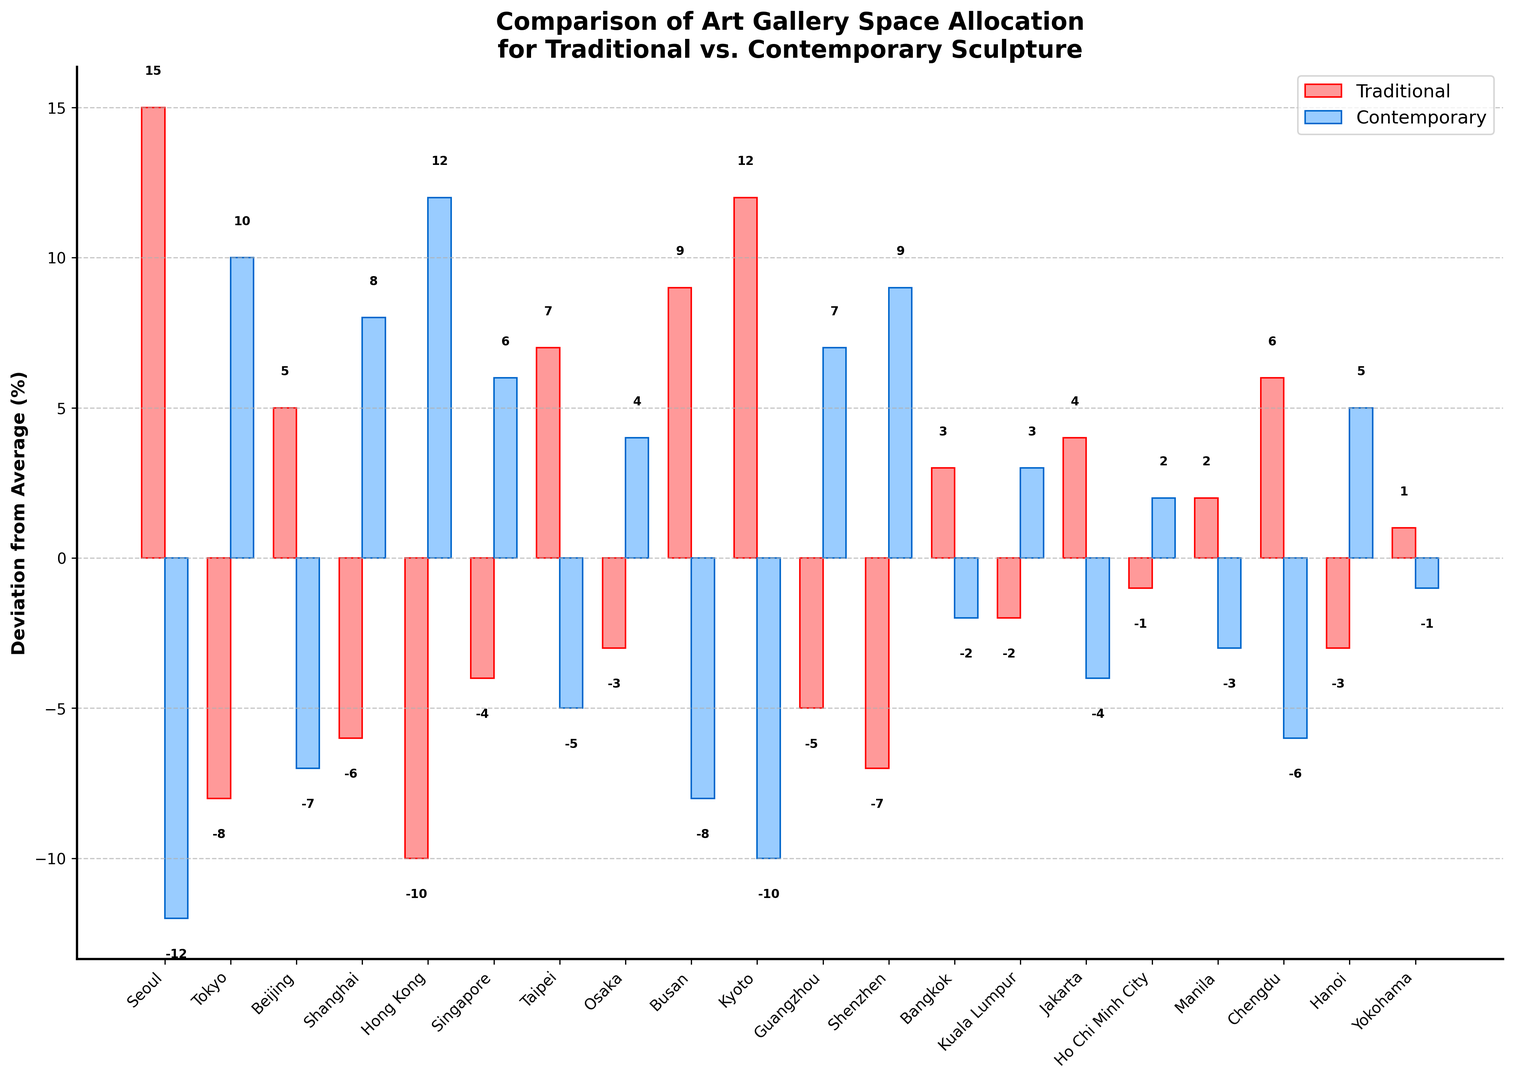Which city has the highest positive deviation for traditional sculpture space allocation? To find the city with the highest positive deviation, look for the highest bar in the "Traditional" category. The tallest red bar corresponds to Seoul, which has a deviation of 15%.
Answer: Seoul Which city has the highest positive deviation for contemporary sculpture space allocation? To find the city with the highest positive deviation, look for the highest bar in the "Contemporary" category. The tallest blue bar corresponds to Hong Kong, which has a deviation of 12%.
Answer: Hong Kong Which city shows an equal positive and negative deviation for traditional and contemporary sculptures respectively? Check for the city where the heights of the red and blue bars are equal but in opposite directions. Seoul has +15% for traditional and -12% for contemporary.
Answer: None What is the difference in deviation between traditional and contemporary sculptures in Tokyo? Tokyo has a traditional deviation of -8% and a contemporary deviation of 10%. The difference is calculated as: 10 - (-8) = 10 + 8 = 18%.
Answer: 18% Which city shows the smallest absolute deviation for contemporary sculptures? The smallest absolute deviation is found by looking for the shortest blue bar, which indicates the deviation closest to zero. Yokohama has the smallest blue bar with a deviation of -1%.
Answer: Yokohama In which city is the deviation for traditional sculpture space the lowest? The lowest negative deviation for traditional sculpture space allocation is seen in Hong Kong with a deviation of -10%.
Answer: Hong Kong Which city has the same magnitude of deviation but in opposite directions for traditional and contemporary sculptures? Look for cities where the absolute values of deviations are the same but one is positive and the other is negative. Seoul has +15 for traditional and -12 for contemporary; Kyoto has +12 for traditional and -10 for contemporary. They are not exact matches. The closest is Jakarta with +4 and -4.
Answer: Jakarta What is the combined deviation for both traditional and contemporary sculptures in Chengdu? Chengdu has a traditional deviation of 6% and a contemporary deviation of -6%. The combined deviation is: 6 + (-6) = 0%.
Answer: 0% Which cities show a positive deviation for contemporary sculpture space allocation? Check the blue bars above the zero line, indicating positive deviations: Tokyo, Shanghai, Hong Kong, Singapore, Osaka, Guangzhou, Shenzhen, Hanoi.
Answer: 8 cities Among the cities with positive deviations for traditional sculptures, which city shows the highest negative deviation for contemporary sculptures? Examine the list of cities with positive traditional deviations and find the one with the highest negative deviation for contemporary sculptures. Seoul has +15 for traditional and -12 for contemporary.
Answer: Seoul 